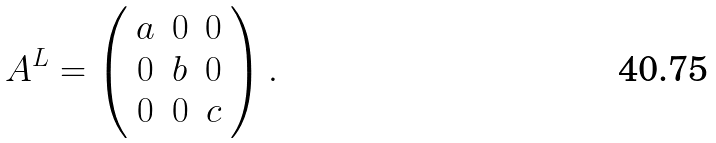<formula> <loc_0><loc_0><loc_500><loc_500>A ^ { L } = \left ( \begin{array} { c c c } a & 0 & 0 \\ 0 & b & 0 \\ 0 & 0 & c \end{array} \right ) .</formula> 